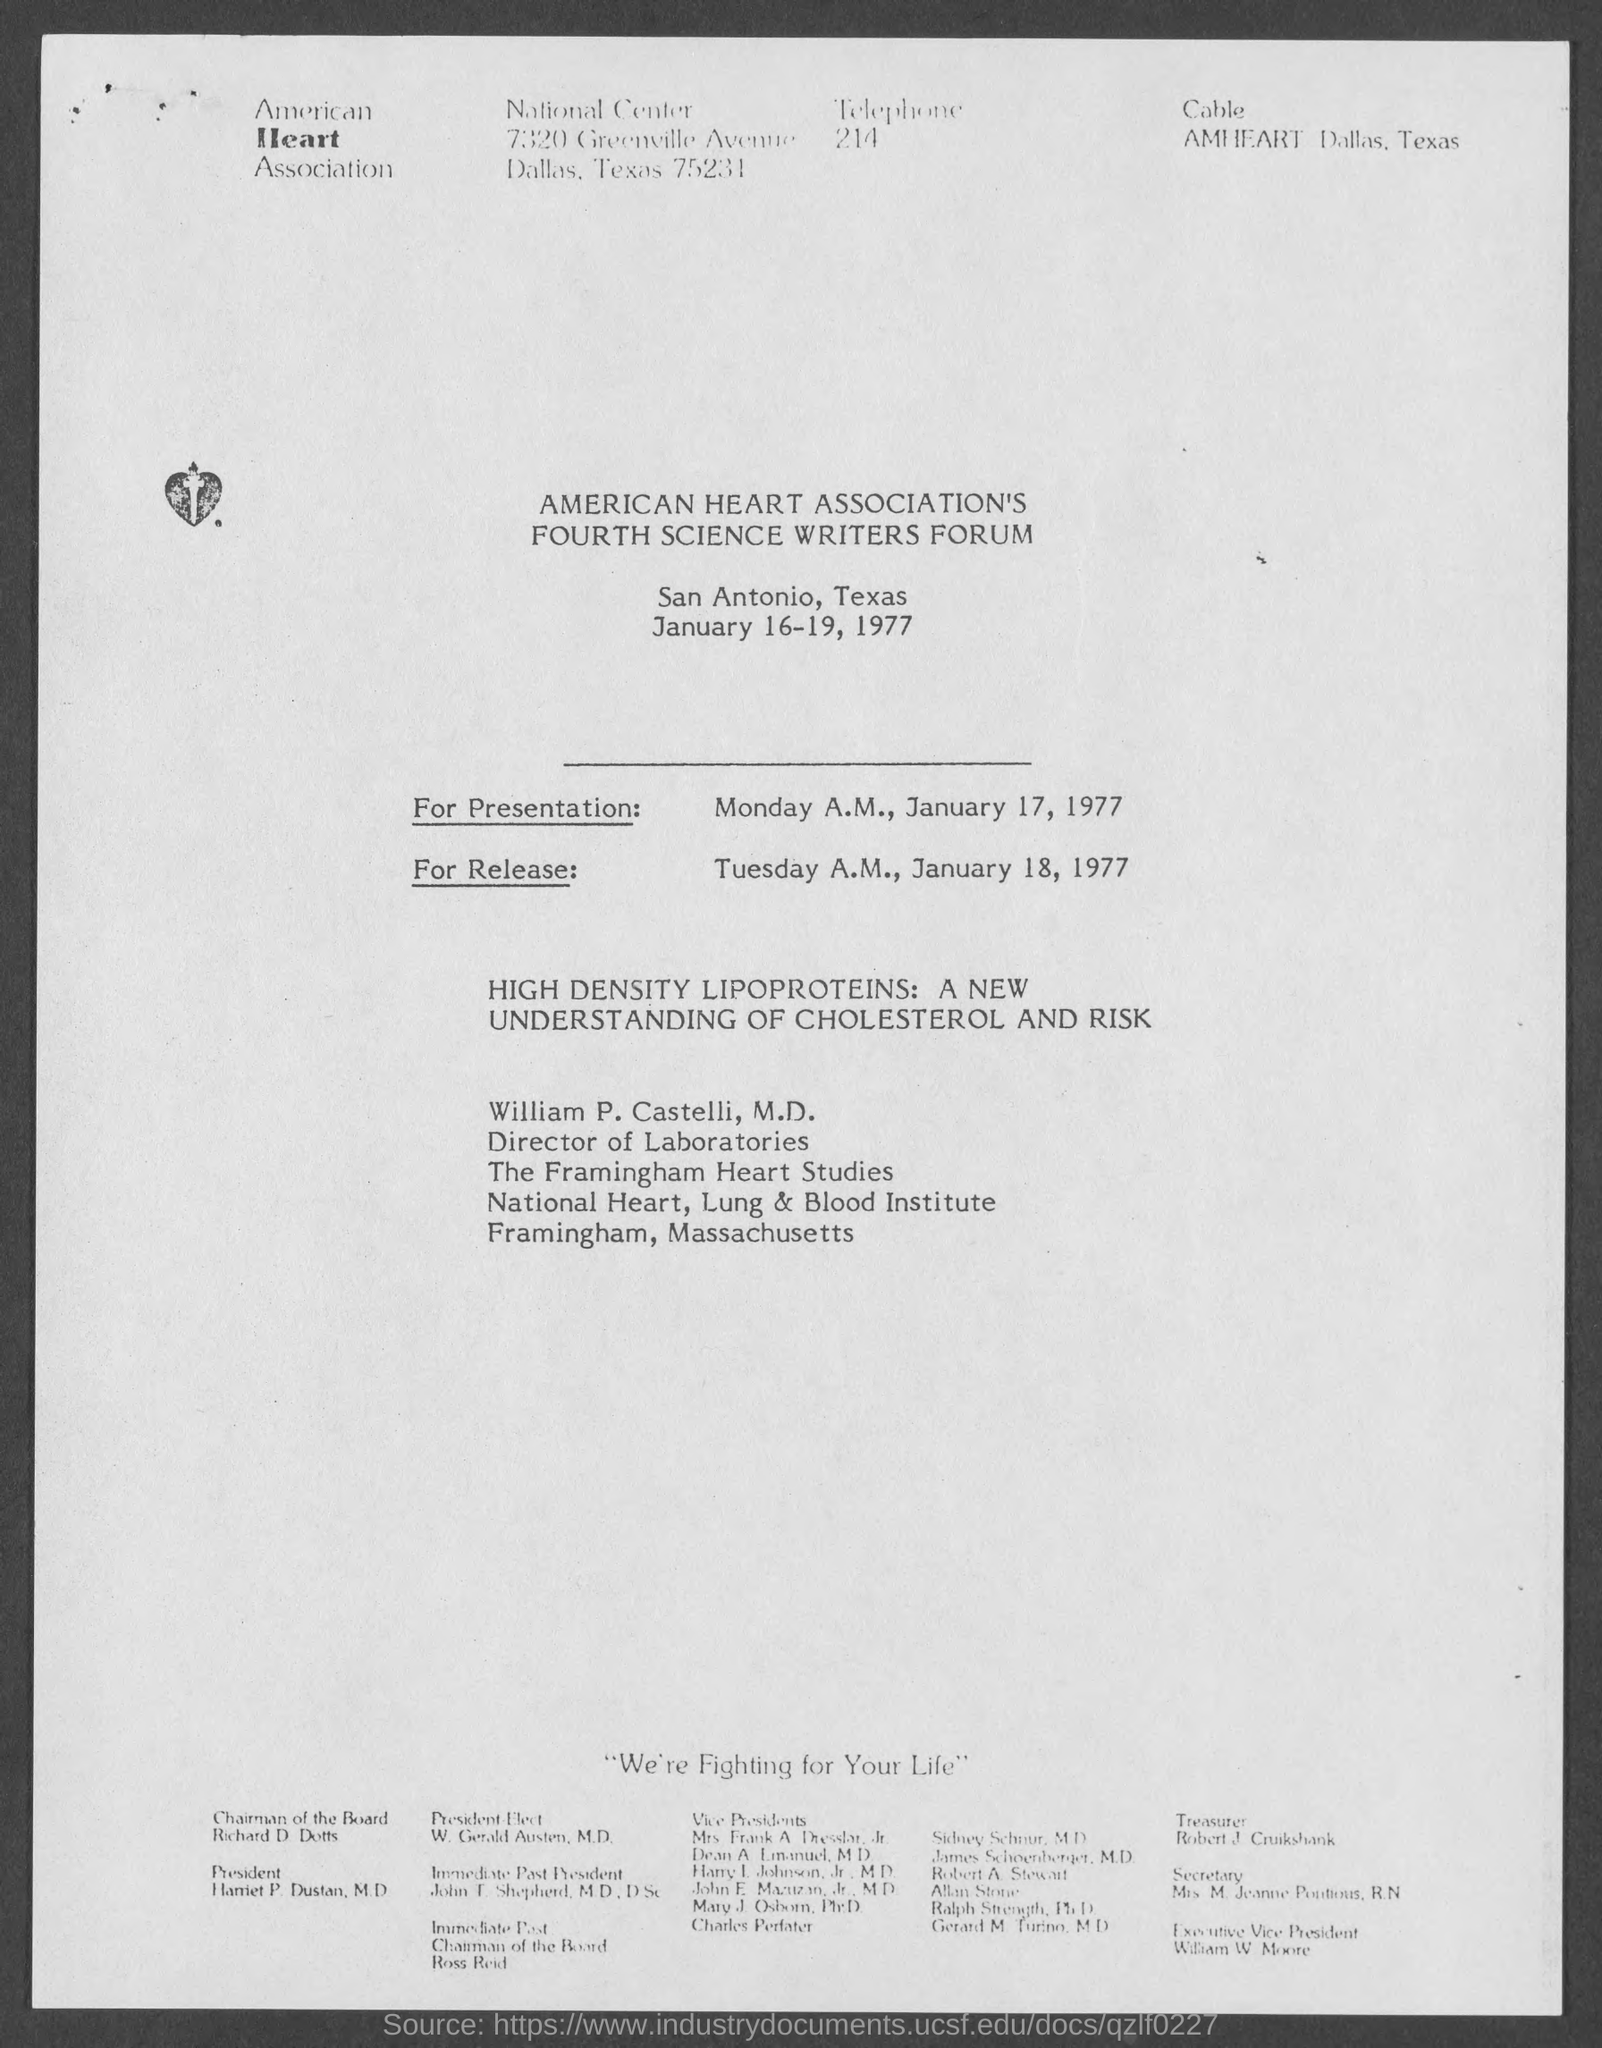Where is it held?
Give a very brief answer. SAN ANTONIO, TEXAS. 